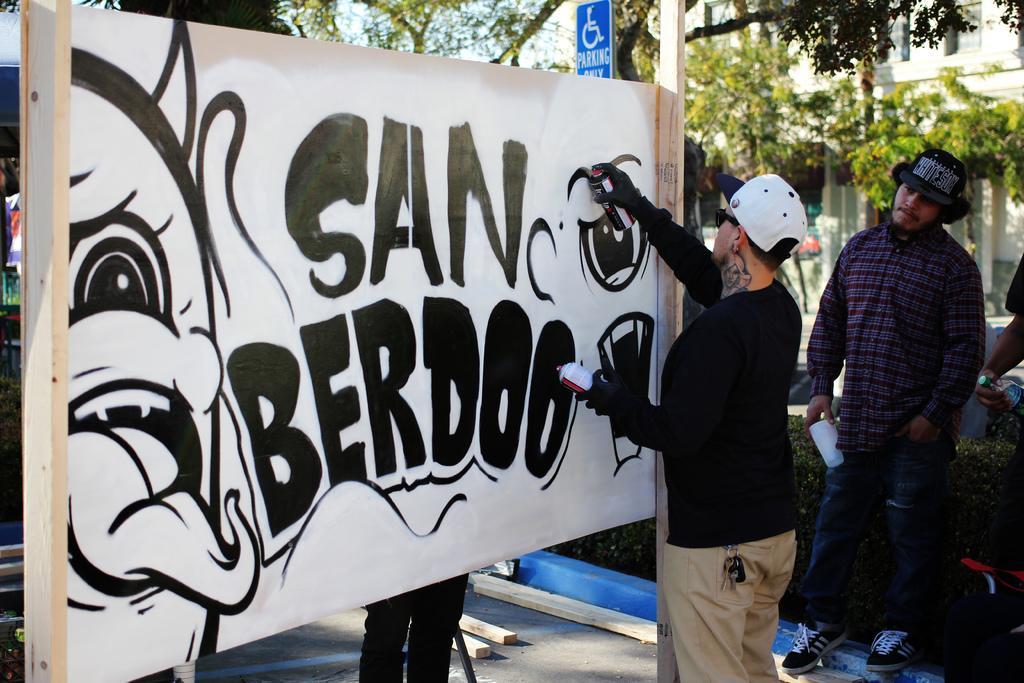Can you describe this image briefly? There is a person wearing cap and goggles is holding bottles. In front of him there is a white board with poles. On that he is painting. Near to him there is a person standing and wearing a hat and holding something in the hand. On the ground there are wooden poles. In the back there are trees. Also there is a sign board. 